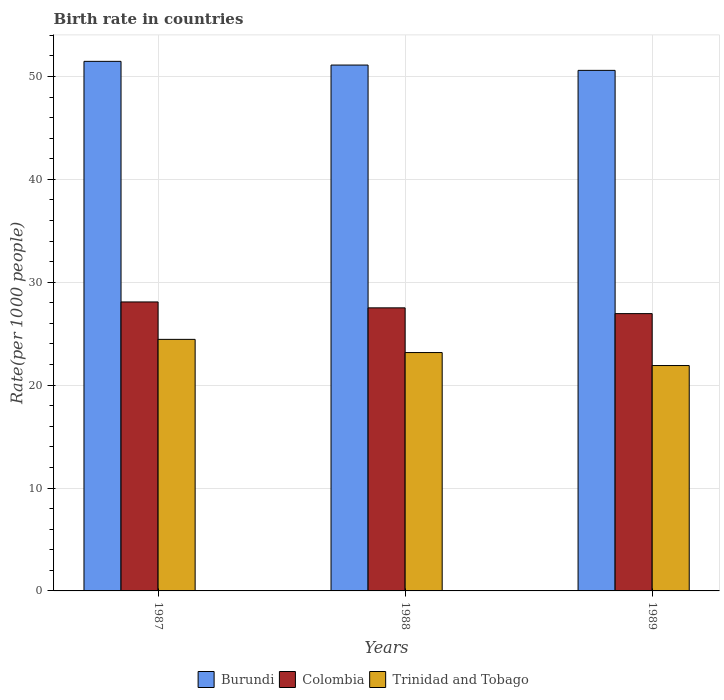How many bars are there on the 2nd tick from the right?
Give a very brief answer. 3. What is the label of the 2nd group of bars from the left?
Make the answer very short. 1988. In how many cases, is the number of bars for a given year not equal to the number of legend labels?
Make the answer very short. 0. What is the birth rate in Trinidad and Tobago in 1988?
Offer a very short reply. 23.17. Across all years, what is the maximum birth rate in Colombia?
Give a very brief answer. 28.09. Across all years, what is the minimum birth rate in Colombia?
Give a very brief answer. 26.95. In which year was the birth rate in Trinidad and Tobago maximum?
Your response must be concise. 1987. What is the total birth rate in Colombia in the graph?
Your answer should be compact. 82.55. What is the difference between the birth rate in Burundi in 1987 and that in 1989?
Offer a very short reply. 0.88. What is the difference between the birth rate in Trinidad and Tobago in 1987 and the birth rate in Colombia in 1989?
Offer a terse response. -2.5. What is the average birth rate in Trinidad and Tobago per year?
Your answer should be compact. 23.17. In the year 1989, what is the difference between the birth rate in Colombia and birth rate in Trinidad and Tobago?
Your response must be concise. 5.05. In how many years, is the birth rate in Burundi greater than 4?
Give a very brief answer. 3. What is the ratio of the birth rate in Burundi in 1988 to that in 1989?
Your answer should be very brief. 1.01. Is the birth rate in Colombia in 1987 less than that in 1988?
Provide a short and direct response. No. Is the difference between the birth rate in Colombia in 1987 and 1989 greater than the difference between the birth rate in Trinidad and Tobago in 1987 and 1989?
Provide a succinct answer. No. What is the difference between the highest and the second highest birth rate in Colombia?
Provide a succinct answer. 0.57. What is the difference between the highest and the lowest birth rate in Colombia?
Your answer should be very brief. 1.13. What does the 2nd bar from the left in 1989 represents?
Offer a terse response. Colombia. What does the 3rd bar from the right in 1987 represents?
Provide a short and direct response. Burundi. Does the graph contain any zero values?
Give a very brief answer. No. Does the graph contain grids?
Ensure brevity in your answer.  Yes. Where does the legend appear in the graph?
Provide a succinct answer. Bottom center. How are the legend labels stacked?
Offer a very short reply. Horizontal. What is the title of the graph?
Your answer should be compact. Birth rate in countries. Does "Arab World" appear as one of the legend labels in the graph?
Provide a short and direct response. No. What is the label or title of the Y-axis?
Ensure brevity in your answer.  Rate(per 1000 people). What is the Rate(per 1000 people) of Burundi in 1987?
Your answer should be very brief. 51.47. What is the Rate(per 1000 people) in Colombia in 1987?
Offer a very short reply. 28.09. What is the Rate(per 1000 people) of Trinidad and Tobago in 1987?
Ensure brevity in your answer.  24.45. What is the Rate(per 1000 people) of Burundi in 1988?
Your answer should be very brief. 51.11. What is the Rate(per 1000 people) in Colombia in 1988?
Your answer should be compact. 27.51. What is the Rate(per 1000 people) in Trinidad and Tobago in 1988?
Your response must be concise. 23.17. What is the Rate(per 1000 people) in Burundi in 1989?
Offer a very short reply. 50.59. What is the Rate(per 1000 people) of Colombia in 1989?
Ensure brevity in your answer.  26.95. What is the Rate(per 1000 people) in Trinidad and Tobago in 1989?
Make the answer very short. 21.91. Across all years, what is the maximum Rate(per 1000 people) of Burundi?
Offer a very short reply. 51.47. Across all years, what is the maximum Rate(per 1000 people) of Colombia?
Give a very brief answer. 28.09. Across all years, what is the maximum Rate(per 1000 people) in Trinidad and Tobago?
Your answer should be compact. 24.45. Across all years, what is the minimum Rate(per 1000 people) of Burundi?
Offer a very short reply. 50.59. Across all years, what is the minimum Rate(per 1000 people) in Colombia?
Your response must be concise. 26.95. Across all years, what is the minimum Rate(per 1000 people) of Trinidad and Tobago?
Give a very brief answer. 21.91. What is the total Rate(per 1000 people) of Burundi in the graph?
Make the answer very short. 153.17. What is the total Rate(per 1000 people) in Colombia in the graph?
Keep it short and to the point. 82.55. What is the total Rate(per 1000 people) in Trinidad and Tobago in the graph?
Your response must be concise. 69.52. What is the difference between the Rate(per 1000 people) of Burundi in 1987 and that in 1988?
Provide a succinct answer. 0.36. What is the difference between the Rate(per 1000 people) in Colombia in 1987 and that in 1988?
Keep it short and to the point. 0.57. What is the difference between the Rate(per 1000 people) of Trinidad and Tobago in 1987 and that in 1988?
Ensure brevity in your answer.  1.28. What is the difference between the Rate(per 1000 people) of Burundi in 1987 and that in 1989?
Your answer should be very brief. 0.88. What is the difference between the Rate(per 1000 people) of Colombia in 1987 and that in 1989?
Make the answer very short. 1.13. What is the difference between the Rate(per 1000 people) in Trinidad and Tobago in 1987 and that in 1989?
Your answer should be compact. 2.54. What is the difference between the Rate(per 1000 people) of Burundi in 1988 and that in 1989?
Your answer should be compact. 0.52. What is the difference between the Rate(per 1000 people) of Colombia in 1988 and that in 1989?
Make the answer very short. 0.56. What is the difference between the Rate(per 1000 people) in Trinidad and Tobago in 1988 and that in 1989?
Make the answer very short. 1.26. What is the difference between the Rate(per 1000 people) in Burundi in 1987 and the Rate(per 1000 people) in Colombia in 1988?
Keep it short and to the point. 23.96. What is the difference between the Rate(per 1000 people) of Burundi in 1987 and the Rate(per 1000 people) of Trinidad and Tobago in 1988?
Keep it short and to the point. 28.3. What is the difference between the Rate(per 1000 people) of Colombia in 1987 and the Rate(per 1000 people) of Trinidad and Tobago in 1988?
Keep it short and to the point. 4.92. What is the difference between the Rate(per 1000 people) of Burundi in 1987 and the Rate(per 1000 people) of Colombia in 1989?
Offer a terse response. 24.52. What is the difference between the Rate(per 1000 people) of Burundi in 1987 and the Rate(per 1000 people) of Trinidad and Tobago in 1989?
Make the answer very short. 29.56. What is the difference between the Rate(per 1000 people) in Colombia in 1987 and the Rate(per 1000 people) in Trinidad and Tobago in 1989?
Provide a succinct answer. 6.18. What is the difference between the Rate(per 1000 people) of Burundi in 1988 and the Rate(per 1000 people) of Colombia in 1989?
Provide a short and direct response. 24.16. What is the difference between the Rate(per 1000 people) in Burundi in 1988 and the Rate(per 1000 people) in Trinidad and Tobago in 1989?
Your answer should be compact. 29.2. What is the difference between the Rate(per 1000 people) in Colombia in 1988 and the Rate(per 1000 people) in Trinidad and Tobago in 1989?
Offer a very short reply. 5.61. What is the average Rate(per 1000 people) in Burundi per year?
Give a very brief answer. 51.06. What is the average Rate(per 1000 people) in Colombia per year?
Your answer should be very brief. 27.52. What is the average Rate(per 1000 people) in Trinidad and Tobago per year?
Offer a very short reply. 23.17. In the year 1987, what is the difference between the Rate(per 1000 people) in Burundi and Rate(per 1000 people) in Colombia?
Offer a terse response. 23.38. In the year 1987, what is the difference between the Rate(per 1000 people) in Burundi and Rate(per 1000 people) in Trinidad and Tobago?
Offer a terse response. 27.02. In the year 1987, what is the difference between the Rate(per 1000 people) in Colombia and Rate(per 1000 people) in Trinidad and Tobago?
Your answer should be compact. 3.64. In the year 1988, what is the difference between the Rate(per 1000 people) of Burundi and Rate(per 1000 people) of Colombia?
Offer a terse response. 23.6. In the year 1988, what is the difference between the Rate(per 1000 people) in Burundi and Rate(per 1000 people) in Trinidad and Tobago?
Offer a terse response. 27.94. In the year 1988, what is the difference between the Rate(per 1000 people) of Colombia and Rate(per 1000 people) of Trinidad and Tobago?
Provide a succinct answer. 4.34. In the year 1989, what is the difference between the Rate(per 1000 people) in Burundi and Rate(per 1000 people) in Colombia?
Provide a succinct answer. 23.64. In the year 1989, what is the difference between the Rate(per 1000 people) in Burundi and Rate(per 1000 people) in Trinidad and Tobago?
Make the answer very short. 28.69. In the year 1989, what is the difference between the Rate(per 1000 people) in Colombia and Rate(per 1000 people) in Trinidad and Tobago?
Offer a terse response. 5.05. What is the ratio of the Rate(per 1000 people) in Burundi in 1987 to that in 1988?
Ensure brevity in your answer.  1.01. What is the ratio of the Rate(per 1000 people) of Colombia in 1987 to that in 1988?
Provide a succinct answer. 1.02. What is the ratio of the Rate(per 1000 people) of Trinidad and Tobago in 1987 to that in 1988?
Offer a terse response. 1.06. What is the ratio of the Rate(per 1000 people) of Burundi in 1987 to that in 1989?
Your response must be concise. 1.02. What is the ratio of the Rate(per 1000 people) in Colombia in 1987 to that in 1989?
Make the answer very short. 1.04. What is the ratio of the Rate(per 1000 people) of Trinidad and Tobago in 1987 to that in 1989?
Provide a short and direct response. 1.12. What is the ratio of the Rate(per 1000 people) in Burundi in 1988 to that in 1989?
Offer a very short reply. 1.01. What is the ratio of the Rate(per 1000 people) in Colombia in 1988 to that in 1989?
Offer a terse response. 1.02. What is the ratio of the Rate(per 1000 people) in Trinidad and Tobago in 1988 to that in 1989?
Give a very brief answer. 1.06. What is the difference between the highest and the second highest Rate(per 1000 people) of Burundi?
Provide a short and direct response. 0.36. What is the difference between the highest and the second highest Rate(per 1000 people) in Colombia?
Provide a short and direct response. 0.57. What is the difference between the highest and the second highest Rate(per 1000 people) in Trinidad and Tobago?
Ensure brevity in your answer.  1.28. What is the difference between the highest and the lowest Rate(per 1000 people) of Burundi?
Provide a succinct answer. 0.88. What is the difference between the highest and the lowest Rate(per 1000 people) in Colombia?
Provide a short and direct response. 1.13. What is the difference between the highest and the lowest Rate(per 1000 people) of Trinidad and Tobago?
Give a very brief answer. 2.54. 